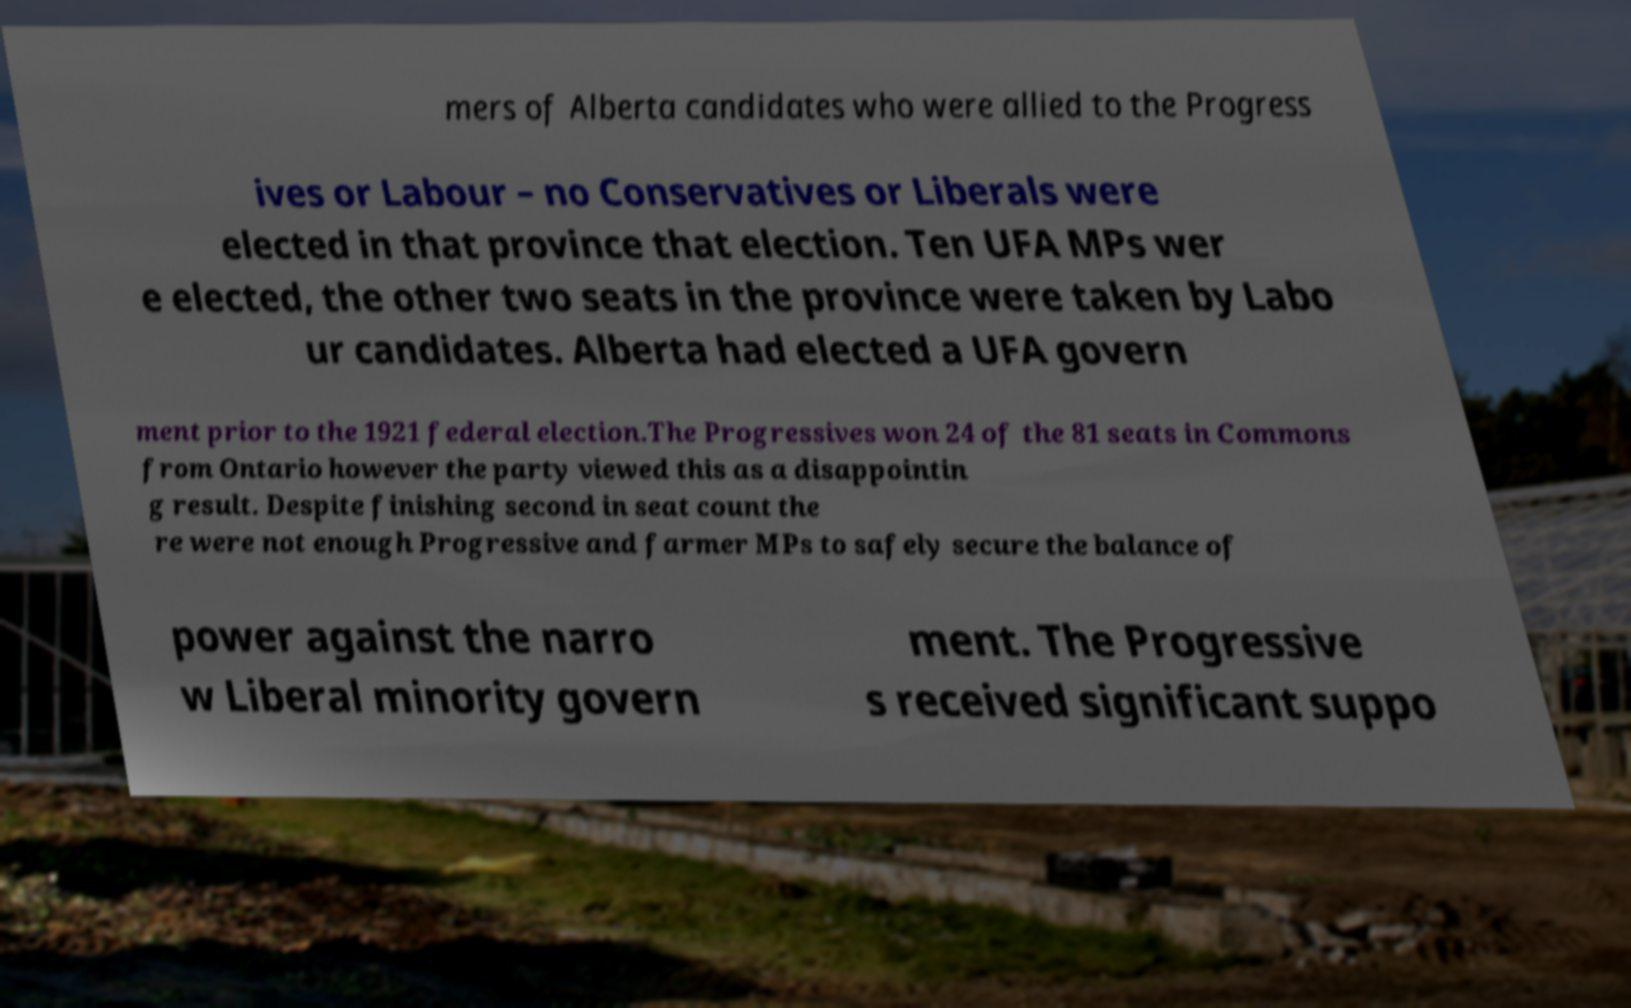For documentation purposes, I need the text within this image transcribed. Could you provide that? mers of Alberta candidates who were allied to the Progress ives or Labour – no Conservatives or Liberals were elected in that province that election. Ten UFA MPs wer e elected, the other two seats in the province were taken by Labo ur candidates. Alberta had elected a UFA govern ment prior to the 1921 federal election.The Progressives won 24 of the 81 seats in Commons from Ontario however the party viewed this as a disappointin g result. Despite finishing second in seat count the re were not enough Progressive and farmer MPs to safely secure the balance of power against the narro w Liberal minority govern ment. The Progressive s received significant suppo 